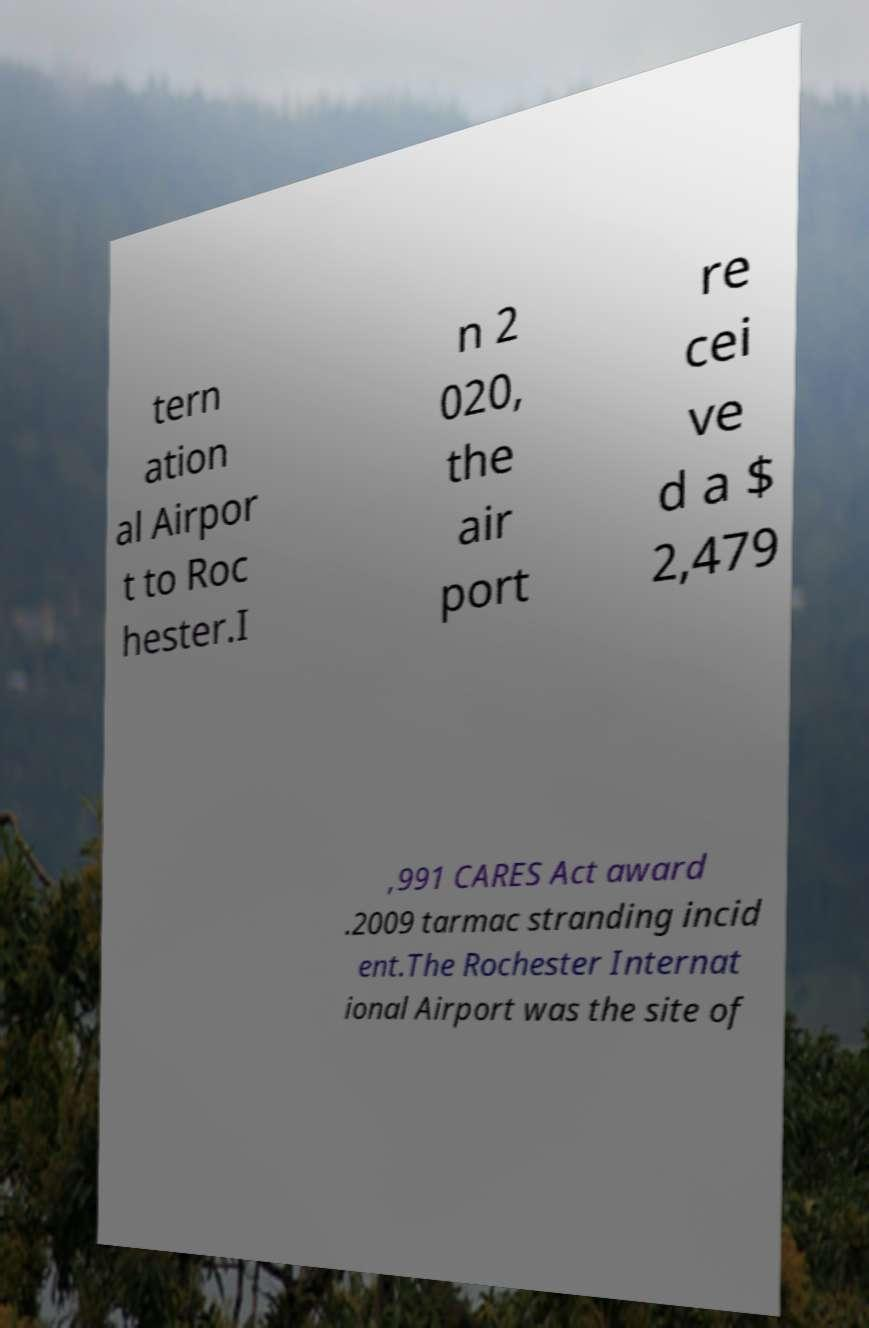Please identify and transcribe the text found in this image. tern ation al Airpor t to Roc hester.I n 2 020, the air port re cei ve d a $ 2,479 ,991 CARES Act award .2009 tarmac stranding incid ent.The Rochester Internat ional Airport was the site of 